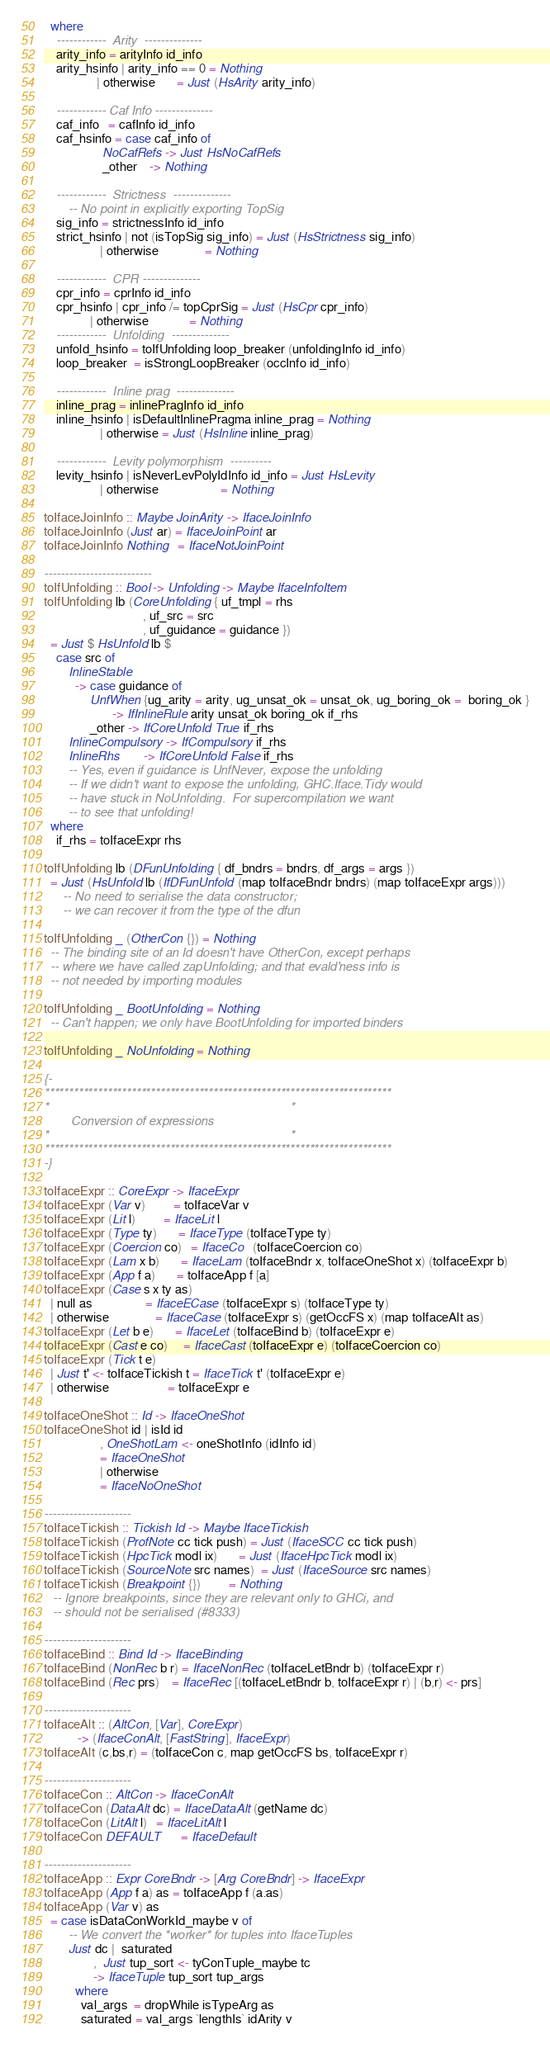Convert code to text. <code><loc_0><loc_0><loc_500><loc_500><_Haskell_>  where
    ------------  Arity  --------------
    arity_info = arityInfo id_info
    arity_hsinfo | arity_info == 0 = Nothing
                 | otherwise       = Just (HsArity arity_info)

    ------------ Caf Info --------------
    caf_info   = cafInfo id_info
    caf_hsinfo = case caf_info of
                   NoCafRefs -> Just HsNoCafRefs
                   _other    -> Nothing

    ------------  Strictness  --------------
        -- No point in explicitly exporting TopSig
    sig_info = strictnessInfo id_info
    strict_hsinfo | not (isTopSig sig_info) = Just (HsStrictness sig_info)
                  | otherwise               = Nothing

    ------------  CPR --------------
    cpr_info = cprInfo id_info
    cpr_hsinfo | cpr_info /= topCprSig = Just (HsCpr cpr_info)
               | otherwise             = Nothing
    ------------  Unfolding  --------------
    unfold_hsinfo = toIfUnfolding loop_breaker (unfoldingInfo id_info)
    loop_breaker  = isStrongLoopBreaker (occInfo id_info)

    ------------  Inline prag  --------------
    inline_prag = inlinePragInfo id_info
    inline_hsinfo | isDefaultInlinePragma inline_prag = Nothing
                  | otherwise = Just (HsInline inline_prag)

    ------------  Levity polymorphism  ----------
    levity_hsinfo | isNeverLevPolyIdInfo id_info = Just HsLevity
                  | otherwise                    = Nothing

toIfaceJoinInfo :: Maybe JoinArity -> IfaceJoinInfo
toIfaceJoinInfo (Just ar) = IfaceJoinPoint ar
toIfaceJoinInfo Nothing   = IfaceNotJoinPoint

--------------------------
toIfUnfolding :: Bool -> Unfolding -> Maybe IfaceInfoItem
toIfUnfolding lb (CoreUnfolding { uf_tmpl = rhs
                                , uf_src = src
                                , uf_guidance = guidance })
  = Just $ HsUnfold lb $
    case src of
        InlineStable
          -> case guidance of
               UnfWhen {ug_arity = arity, ug_unsat_ok = unsat_ok, ug_boring_ok =  boring_ok }
                      -> IfInlineRule arity unsat_ok boring_ok if_rhs
               _other -> IfCoreUnfold True if_rhs
        InlineCompulsory -> IfCompulsory if_rhs
        InlineRhs        -> IfCoreUnfold False if_rhs
        -- Yes, even if guidance is UnfNever, expose the unfolding
        -- If we didn't want to expose the unfolding, GHC.Iface.Tidy would
        -- have stuck in NoUnfolding.  For supercompilation we want
        -- to see that unfolding!
  where
    if_rhs = toIfaceExpr rhs

toIfUnfolding lb (DFunUnfolding { df_bndrs = bndrs, df_args = args })
  = Just (HsUnfold lb (IfDFunUnfold (map toIfaceBndr bndrs) (map toIfaceExpr args)))
      -- No need to serialise the data constructor;
      -- we can recover it from the type of the dfun

toIfUnfolding _ (OtherCon {}) = Nothing
  -- The binding site of an Id doesn't have OtherCon, except perhaps
  -- where we have called zapUnfolding; and that evald'ness info is
  -- not needed by importing modules

toIfUnfolding _ BootUnfolding = Nothing
  -- Can't happen; we only have BootUnfolding for imported binders

toIfUnfolding _ NoUnfolding = Nothing

{-
************************************************************************
*                                                                      *
        Conversion of expressions
*                                                                      *
************************************************************************
-}

toIfaceExpr :: CoreExpr -> IfaceExpr
toIfaceExpr (Var v)         = toIfaceVar v
toIfaceExpr (Lit l)         = IfaceLit l
toIfaceExpr (Type ty)       = IfaceType (toIfaceType ty)
toIfaceExpr (Coercion co)   = IfaceCo   (toIfaceCoercion co)
toIfaceExpr (Lam x b)       = IfaceLam (toIfaceBndr x, toIfaceOneShot x) (toIfaceExpr b)
toIfaceExpr (App f a)       = toIfaceApp f [a]
toIfaceExpr (Case s x ty as)
  | null as                 = IfaceECase (toIfaceExpr s) (toIfaceType ty)
  | otherwise               = IfaceCase (toIfaceExpr s) (getOccFS x) (map toIfaceAlt as)
toIfaceExpr (Let b e)       = IfaceLet (toIfaceBind b) (toIfaceExpr e)
toIfaceExpr (Cast e co)     = IfaceCast (toIfaceExpr e) (toIfaceCoercion co)
toIfaceExpr (Tick t e)
  | Just t' <- toIfaceTickish t = IfaceTick t' (toIfaceExpr e)
  | otherwise                   = toIfaceExpr e

toIfaceOneShot :: Id -> IfaceOneShot
toIfaceOneShot id | isId id
                  , OneShotLam <- oneShotInfo (idInfo id)
                  = IfaceOneShot
                  | otherwise
                  = IfaceNoOneShot

---------------------
toIfaceTickish :: Tickish Id -> Maybe IfaceTickish
toIfaceTickish (ProfNote cc tick push) = Just (IfaceSCC cc tick push)
toIfaceTickish (HpcTick modl ix)       = Just (IfaceHpcTick modl ix)
toIfaceTickish (SourceNote src names)  = Just (IfaceSource src names)
toIfaceTickish (Breakpoint {})         = Nothing
   -- Ignore breakpoints, since they are relevant only to GHCi, and
   -- should not be serialised (#8333)

---------------------
toIfaceBind :: Bind Id -> IfaceBinding
toIfaceBind (NonRec b r) = IfaceNonRec (toIfaceLetBndr b) (toIfaceExpr r)
toIfaceBind (Rec prs)    = IfaceRec [(toIfaceLetBndr b, toIfaceExpr r) | (b,r) <- prs]

---------------------
toIfaceAlt :: (AltCon, [Var], CoreExpr)
           -> (IfaceConAlt, [FastString], IfaceExpr)
toIfaceAlt (c,bs,r) = (toIfaceCon c, map getOccFS bs, toIfaceExpr r)

---------------------
toIfaceCon :: AltCon -> IfaceConAlt
toIfaceCon (DataAlt dc) = IfaceDataAlt (getName dc)
toIfaceCon (LitAlt l)   = IfaceLitAlt l
toIfaceCon DEFAULT      = IfaceDefault

---------------------
toIfaceApp :: Expr CoreBndr -> [Arg CoreBndr] -> IfaceExpr
toIfaceApp (App f a) as = toIfaceApp f (a:as)
toIfaceApp (Var v) as
  = case isDataConWorkId_maybe v of
        -- We convert the *worker* for tuples into IfaceTuples
        Just dc |  saturated
                ,  Just tup_sort <- tyConTuple_maybe tc
                -> IfaceTuple tup_sort tup_args
          where
            val_args  = dropWhile isTypeArg as
            saturated = val_args `lengthIs` idArity v</code> 